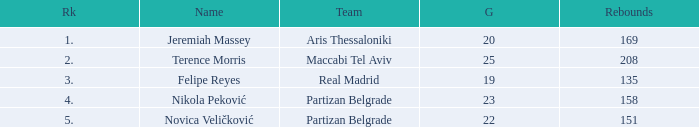I'm looking to parse the entire table for insights. Could you assist me with that? {'header': ['Rk', 'Name', 'Team', 'G', 'Rebounds'], 'rows': [['1.', 'Jeremiah Massey', 'Aris Thessaloniki', '20', '169'], ['2.', 'Terence Morris', 'Maccabi Tel Aviv', '25', '208'], ['3.', 'Felipe Reyes', 'Real Madrid', '19', '135'], ['4.', 'Nikola Peković', 'Partizan Belgrade', '23', '158'], ['5.', 'Novica Veličković', 'Partizan Belgrade', '22', '151']]} What is the number of Games for Partizan Belgrade player Nikola Peković with a Rank of more than 4? None. 